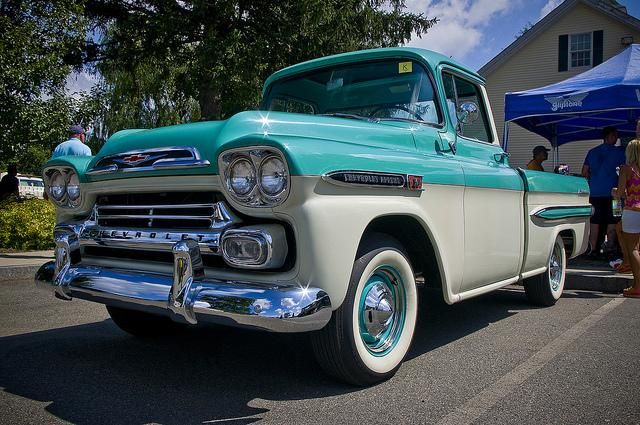What type of vehicle is shown?

Choices:
A) subway
B) bus
C) car
D) train car 